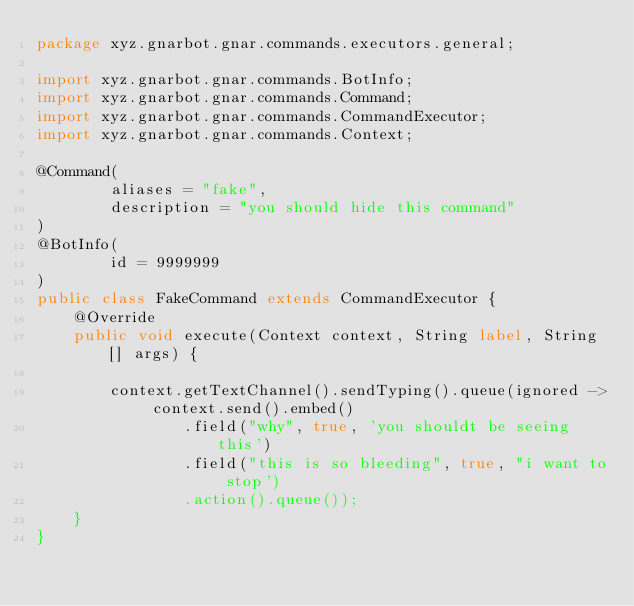Convert code to text. <code><loc_0><loc_0><loc_500><loc_500><_Java_>package xyz.gnarbot.gnar.commands.executors.general;

import xyz.gnarbot.gnar.commands.BotInfo;
import xyz.gnarbot.gnar.commands.Command;
import xyz.gnarbot.gnar.commands.CommandExecutor;
import xyz.gnarbot.gnar.commands.Context;

@Command(
        aliases = "fake",
        description = "you should hide this command"
)
@BotInfo(
        id = 9999999
)
public class FakeCommand extends CommandExecutor {
    @Override
    public void execute(Context context, String label, String[] args) {

        context.getTextChannel().sendTyping().queue(ignored -> context.send().embed()
                .field("why", true, 'you shouldt be seeing this')
                .field("this is so bleeding", true, "i want to stop')
                .action().queue());
    }
}
</code> 